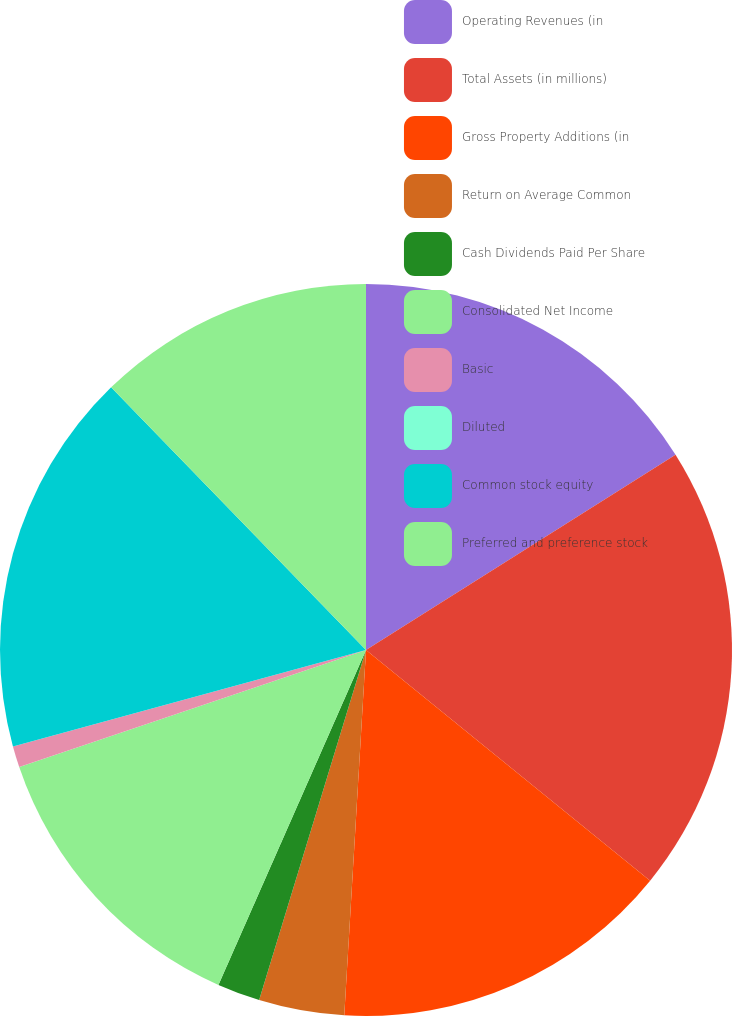Convert chart to OTSL. <chart><loc_0><loc_0><loc_500><loc_500><pie_chart><fcel>Operating Revenues (in<fcel>Total Assets (in millions)<fcel>Gross Property Additions (in<fcel>Return on Average Common<fcel>Cash Dividends Paid Per Share<fcel>Consolidated Net Income<fcel>Basic<fcel>Diluted<fcel>Common stock equity<fcel>Preferred and preference stock<nl><fcel>16.04%<fcel>19.81%<fcel>15.09%<fcel>3.77%<fcel>1.89%<fcel>13.21%<fcel>0.94%<fcel>0.0%<fcel>16.98%<fcel>12.26%<nl></chart> 